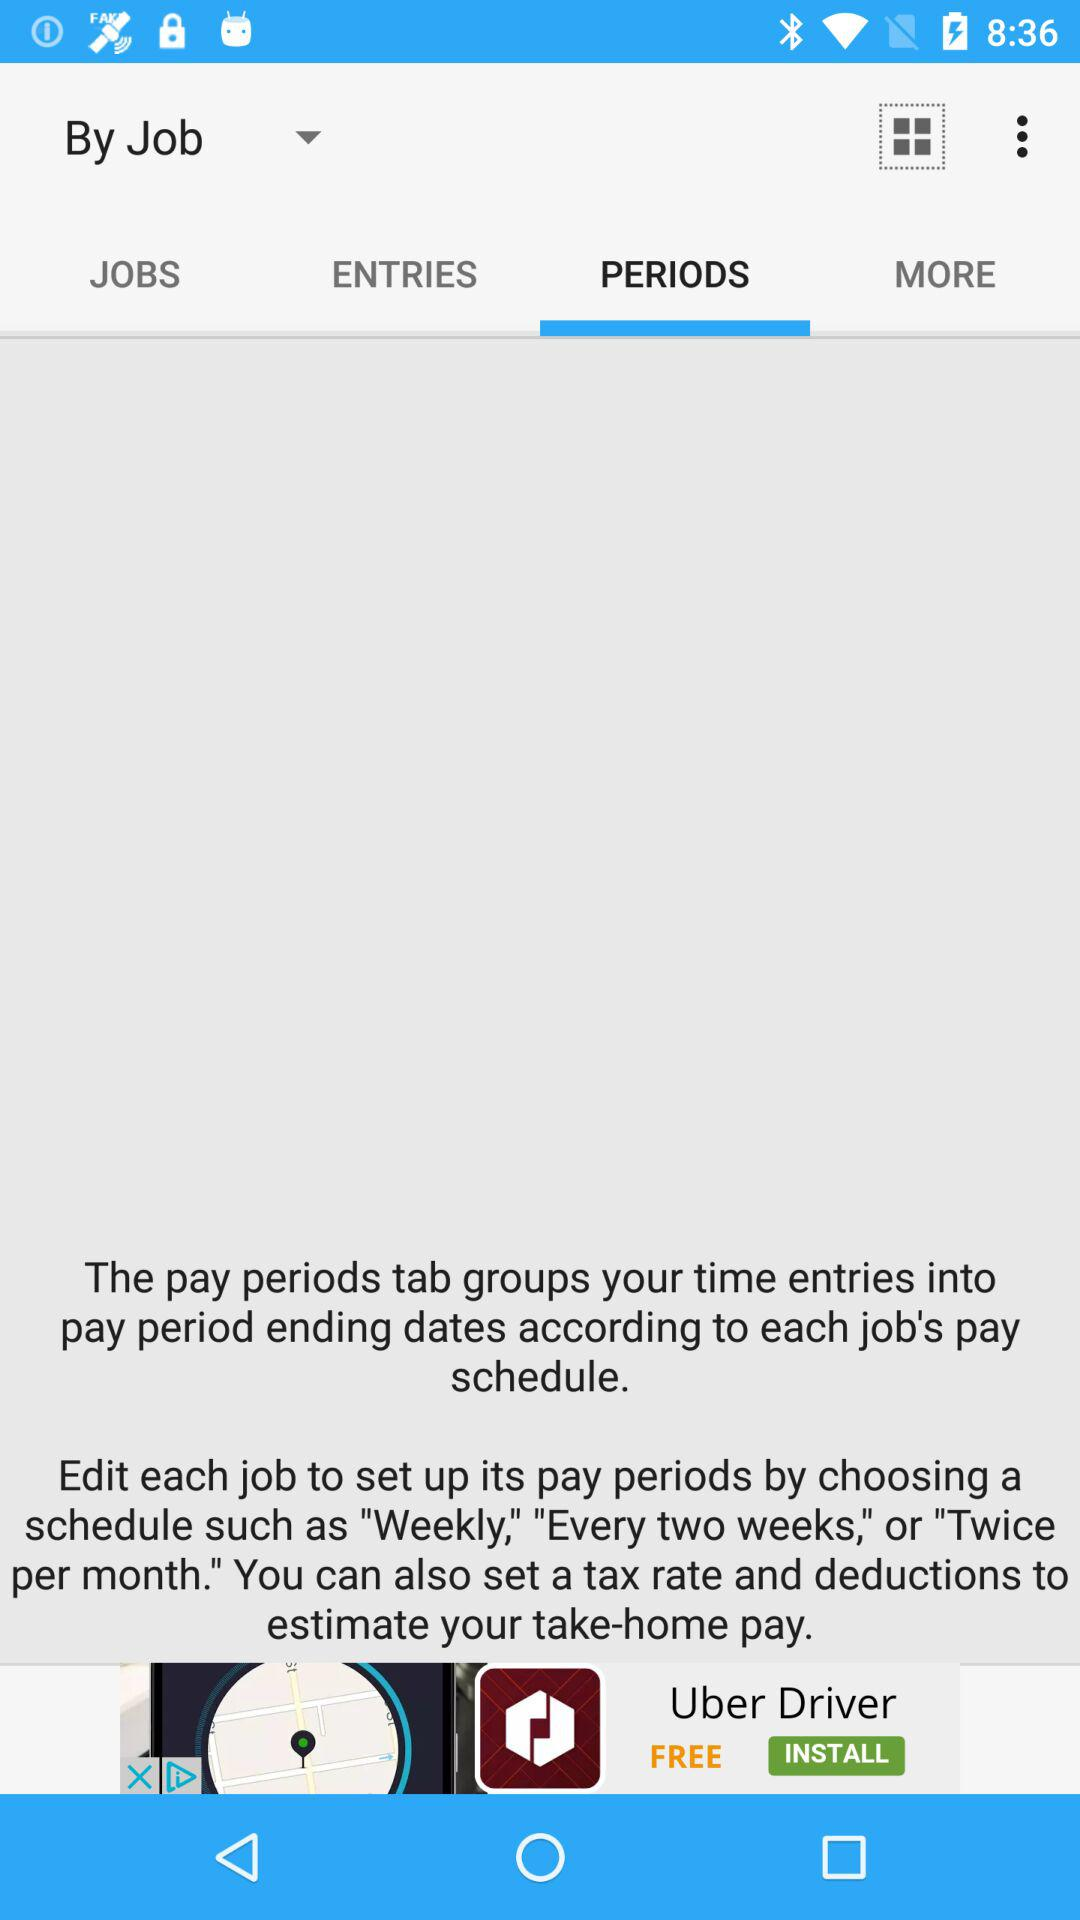Which tab is selected? The selected tab is "PERIODS". 